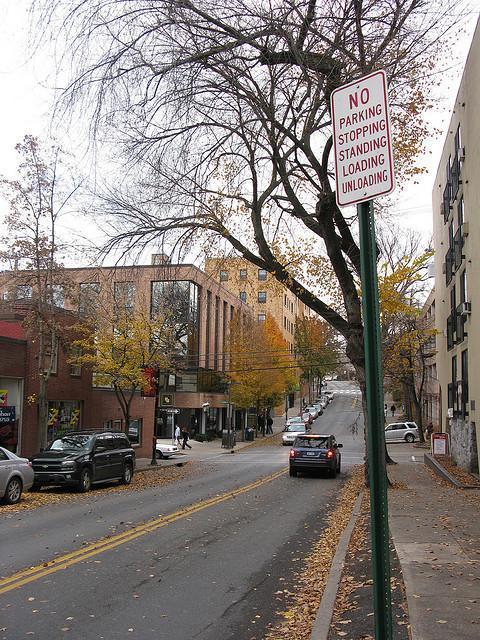How many cars are there?
Give a very brief answer. 2. How many yellow buses are there?
Give a very brief answer. 0. 